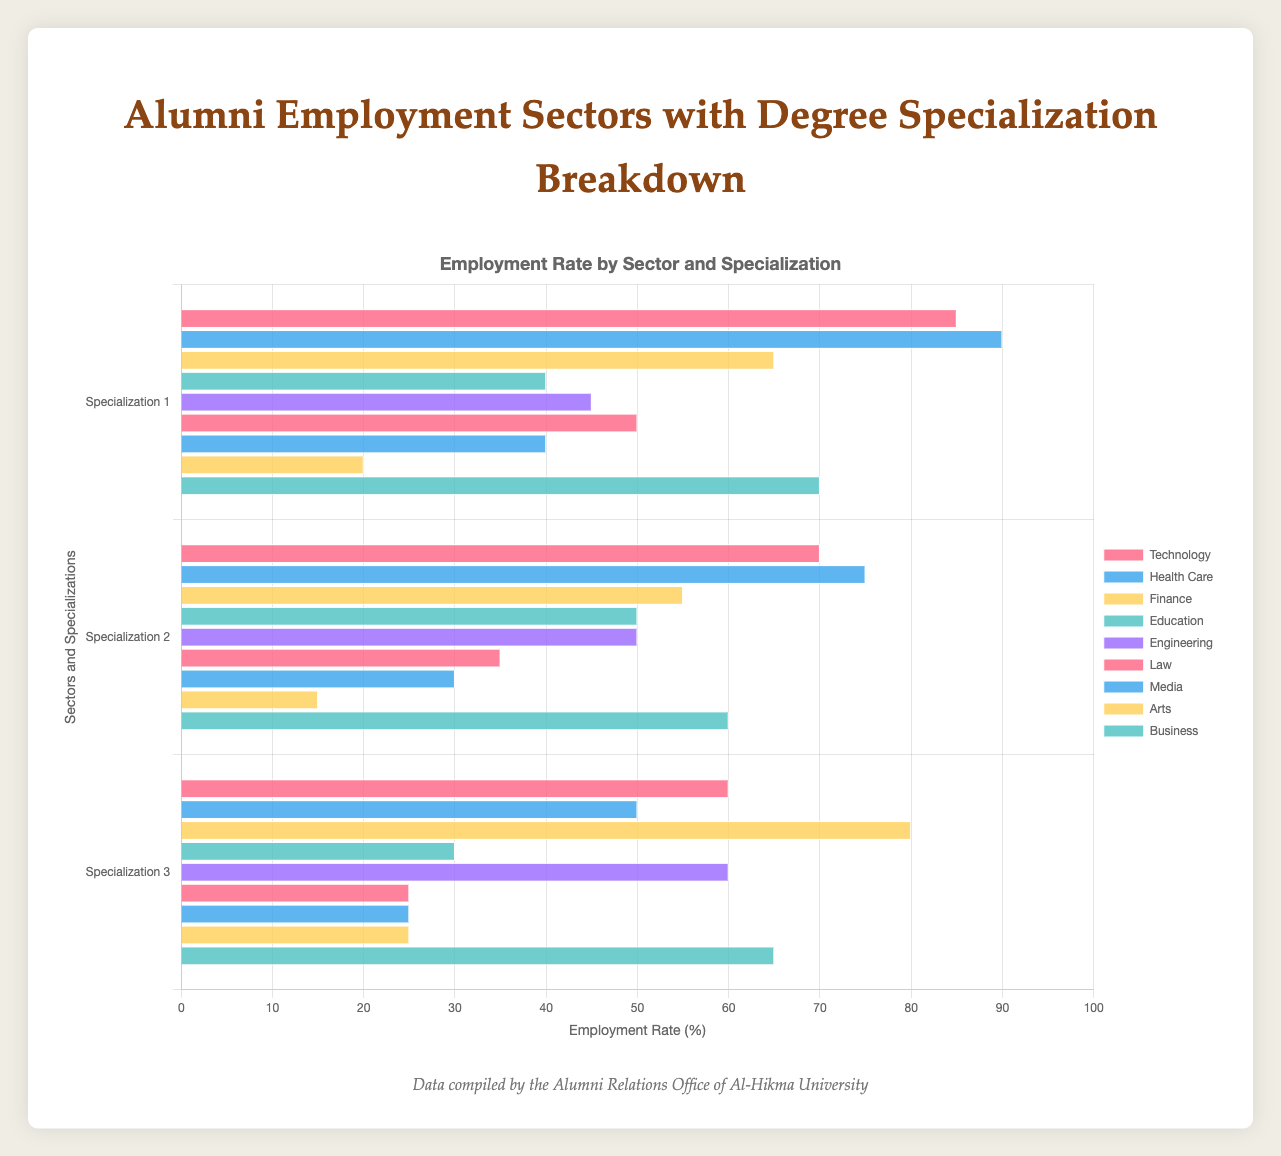What's the highest employment rate in the Technology sector? In the Technology sector, Computer Science has the highest employment rate with 85%.
Answer: 85% Which specialization in the Arts sector has the lowest employment rate? In the Arts sector, the specialization with the lowest employment rate is Performing Arts, at 15%.
Answer: Performing Arts Compare the employment rates in Finance and Engineering. Which has a higher employment rate overall? To determine overall employment, sum the employment rates for each specialization in each sector. Finance: 65 (Accounting) + 55 (Economics) + 80 (Finance) = 200, Engineering: 45 (Civil Engineering) + 50 (Mechanical Engineering) + 60 (Electrical Engineering) = 155. Finance has the higher overall employment rate.
Answer: Finance Which sector has the most uniform employment rates across all specializations? Uniform employment rates indicate that all specializations within the sector have similar values. The Technology sector has rates of 85, 70, and 60 which are relatively close to each other compared to other sectors.
Answer: Technology What is the combined employment rate of Business and Media sectors? Calculate the sum of employment rates in Business and Media sectors. Business: 70 (Business Administration) + 60 (Marketing) + 65 (Management) = 195, Media: 40 (Journalism) + 30 (Public Relations) + 25 (Broadcasting) = 95, Total: 195 + 95 = 290.
Answer: 290 What's the lowest employment rate in the Healthcare sector compared to the highest rate in the Education sector? In the Healthcare sector, the lowest rate is in Public Health (50). In the Education sector, the highest rate is in Secondary Education (50). Both are equal, so the lowest in Healthcare matches the highest in Education.
Answer: Equal / 50 Which sectors have at least one specialization with an employment rate greater than 80%? Sectors with specializations above 80% are Technology (Computer Science at 85) and Healthcare (Nursing at 90). Both sectors meet this condition.
Answer: Technology, Healthcare Compare the employment rates of Corporate Law and Civil Engineering. Which has a higher rate? Corporate Law has an employment rate of 50, while Civil Engineering has a rate of 45. Corporate Law has a higher rate.
Answer: Corporate Law What is the average employment rate for the specializations within the Health Care sector? The average is calculated as (90 + 75 + 50) / 3 = 71.67.
Answer: 71.67 Is there any specialization in the Law sector with a higher employment rate than the lowest in Finance? The lowest in Finance is Economics (55). In Law, both Criminal Law (35) and International Law (25) have lower rates than 55. Only Corporate Law (50) is compared here, which is also less. Therefore, no specialization in Law has a higher rate than the lowest in Finance.
Answer: No 